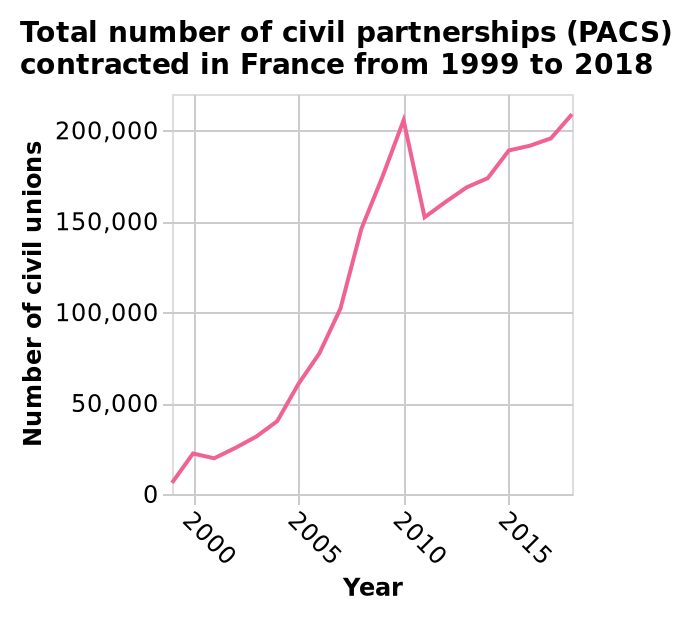<image>
Describe the following image in detail Total number of civil partnerships (PACS) contracted in France from 1999 to 2018 is a line diagram. The x-axis plots Year as linear scale with a minimum of 2000 and a maximum of 2015 while the y-axis shows Number of civil unions along linear scale of range 0 to 200,000. When did civil partnerships in France start to rise?  Civil partnerships in France started to rise from 2000. Did civil partnerships in France start to decrease from 2000? No. Civil partnerships in France started to rise from 2000. 